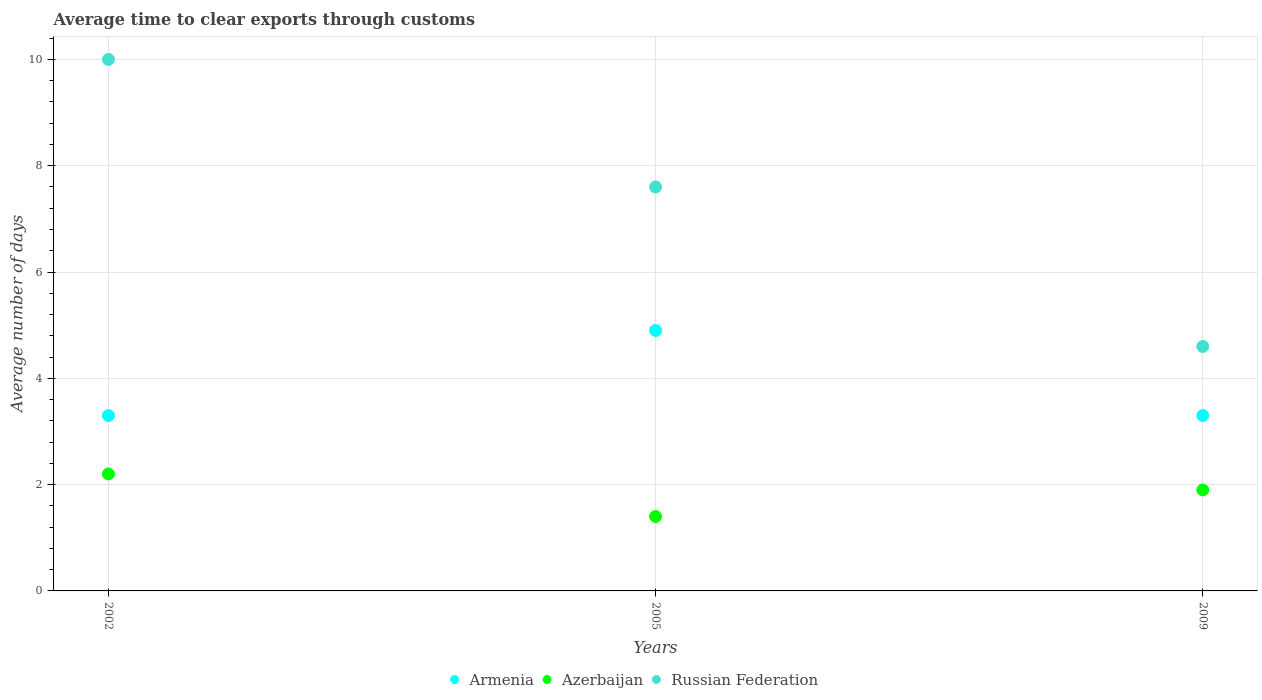What is the average number of days required to clear exports through customs in Russian Federation in 2009?
Your answer should be very brief. 4.6. Across all years, what is the maximum average number of days required to clear exports through customs in Russian Federation?
Ensure brevity in your answer.  10. In which year was the average number of days required to clear exports through customs in Russian Federation maximum?
Provide a succinct answer. 2002. What is the difference between the average number of days required to clear exports through customs in Russian Federation in 2002 and that in 2005?
Keep it short and to the point. 2.4. What is the difference between the average number of days required to clear exports through customs in Armenia in 2002 and the average number of days required to clear exports through customs in Russian Federation in 2009?
Keep it short and to the point. -1.3. What is the average average number of days required to clear exports through customs in Russian Federation per year?
Ensure brevity in your answer.  7.4. In how many years, is the average number of days required to clear exports through customs in Azerbaijan greater than 9.2 days?
Offer a very short reply. 0. What is the ratio of the average number of days required to clear exports through customs in Armenia in 2002 to that in 2005?
Provide a short and direct response. 0.67. Is the average number of days required to clear exports through customs in Azerbaijan in 2002 less than that in 2009?
Offer a very short reply. No. Is the difference between the average number of days required to clear exports through customs in Azerbaijan in 2002 and 2009 greater than the difference between the average number of days required to clear exports through customs in Russian Federation in 2002 and 2009?
Provide a succinct answer. No. What is the difference between the highest and the second highest average number of days required to clear exports through customs in Armenia?
Provide a succinct answer. 1.6. What is the difference between the highest and the lowest average number of days required to clear exports through customs in Russian Federation?
Make the answer very short. 5.4. Is it the case that in every year, the sum of the average number of days required to clear exports through customs in Azerbaijan and average number of days required to clear exports through customs in Armenia  is greater than the average number of days required to clear exports through customs in Russian Federation?
Your answer should be compact. No. Is the average number of days required to clear exports through customs in Armenia strictly greater than the average number of days required to clear exports through customs in Azerbaijan over the years?
Your answer should be compact. Yes. How many dotlines are there?
Give a very brief answer. 3. How many years are there in the graph?
Provide a short and direct response. 3. What is the difference between two consecutive major ticks on the Y-axis?
Ensure brevity in your answer.  2. Are the values on the major ticks of Y-axis written in scientific E-notation?
Provide a short and direct response. No. Does the graph contain any zero values?
Offer a very short reply. No. How many legend labels are there?
Your response must be concise. 3. What is the title of the graph?
Your response must be concise. Average time to clear exports through customs. Does "Iraq" appear as one of the legend labels in the graph?
Your answer should be very brief. No. What is the label or title of the X-axis?
Your answer should be very brief. Years. What is the label or title of the Y-axis?
Offer a terse response. Average number of days. What is the Average number of days of Azerbaijan in 2002?
Give a very brief answer. 2.2. What is the Average number of days of Russian Federation in 2002?
Offer a terse response. 10. What is the Average number of days of Russian Federation in 2005?
Make the answer very short. 7.6. What is the Average number of days of Azerbaijan in 2009?
Offer a very short reply. 1.9. What is the Average number of days in Russian Federation in 2009?
Keep it short and to the point. 4.6. Across all years, what is the maximum Average number of days of Armenia?
Your answer should be compact. 4.9. Across all years, what is the maximum Average number of days in Russian Federation?
Provide a succinct answer. 10. What is the total Average number of days in Armenia in the graph?
Offer a very short reply. 11.5. What is the total Average number of days of Azerbaijan in the graph?
Make the answer very short. 5.5. What is the difference between the Average number of days of Armenia in 2002 and that in 2005?
Offer a very short reply. -1.6. What is the difference between the Average number of days of Russian Federation in 2002 and that in 2009?
Give a very brief answer. 5.4. What is the difference between the Average number of days in Azerbaijan in 2005 and that in 2009?
Ensure brevity in your answer.  -0.5. What is the difference between the Average number of days in Armenia in 2002 and the Average number of days in Azerbaijan in 2005?
Offer a very short reply. 1.9. What is the difference between the Average number of days in Armenia in 2002 and the Average number of days in Russian Federation in 2005?
Make the answer very short. -4.3. What is the difference between the Average number of days of Azerbaijan in 2002 and the Average number of days of Russian Federation in 2005?
Your response must be concise. -5.4. What is the difference between the Average number of days in Armenia in 2002 and the Average number of days in Azerbaijan in 2009?
Your answer should be compact. 1.4. What is the difference between the Average number of days in Armenia in 2005 and the Average number of days in Russian Federation in 2009?
Ensure brevity in your answer.  0.3. What is the average Average number of days of Armenia per year?
Your answer should be very brief. 3.83. What is the average Average number of days of Azerbaijan per year?
Your response must be concise. 1.83. In the year 2005, what is the difference between the Average number of days in Armenia and Average number of days in Russian Federation?
Provide a short and direct response. -2.7. In the year 2009, what is the difference between the Average number of days in Armenia and Average number of days in Azerbaijan?
Your response must be concise. 1.4. What is the ratio of the Average number of days of Armenia in 2002 to that in 2005?
Keep it short and to the point. 0.67. What is the ratio of the Average number of days of Azerbaijan in 2002 to that in 2005?
Make the answer very short. 1.57. What is the ratio of the Average number of days in Russian Federation in 2002 to that in 2005?
Ensure brevity in your answer.  1.32. What is the ratio of the Average number of days in Armenia in 2002 to that in 2009?
Provide a succinct answer. 1. What is the ratio of the Average number of days in Azerbaijan in 2002 to that in 2009?
Offer a very short reply. 1.16. What is the ratio of the Average number of days of Russian Federation in 2002 to that in 2009?
Your answer should be compact. 2.17. What is the ratio of the Average number of days of Armenia in 2005 to that in 2009?
Provide a short and direct response. 1.48. What is the ratio of the Average number of days in Azerbaijan in 2005 to that in 2009?
Provide a succinct answer. 0.74. What is the ratio of the Average number of days in Russian Federation in 2005 to that in 2009?
Offer a very short reply. 1.65. What is the difference between the highest and the second highest Average number of days of Azerbaijan?
Your answer should be compact. 0.3. What is the difference between the highest and the second highest Average number of days of Russian Federation?
Make the answer very short. 2.4. What is the difference between the highest and the lowest Average number of days of Azerbaijan?
Offer a terse response. 0.8. 